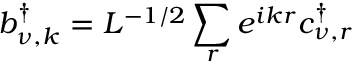<formula> <loc_0><loc_0><loc_500><loc_500>b _ { \nu , k } ^ { \dagger } = L ^ { - 1 / 2 } \sum _ { r } e ^ { i k r } c _ { \nu , r } ^ { \dagger }</formula> 